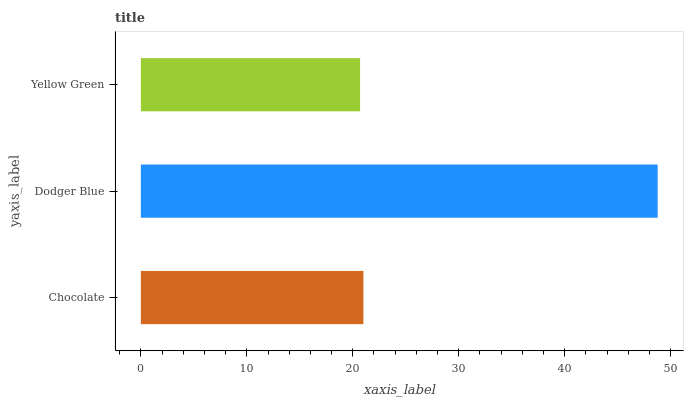Is Yellow Green the minimum?
Answer yes or no. Yes. Is Dodger Blue the maximum?
Answer yes or no. Yes. Is Dodger Blue the minimum?
Answer yes or no. No. Is Yellow Green the maximum?
Answer yes or no. No. Is Dodger Blue greater than Yellow Green?
Answer yes or no. Yes. Is Yellow Green less than Dodger Blue?
Answer yes or no. Yes. Is Yellow Green greater than Dodger Blue?
Answer yes or no. No. Is Dodger Blue less than Yellow Green?
Answer yes or no. No. Is Chocolate the high median?
Answer yes or no. Yes. Is Chocolate the low median?
Answer yes or no. Yes. Is Dodger Blue the high median?
Answer yes or no. No. Is Dodger Blue the low median?
Answer yes or no. No. 